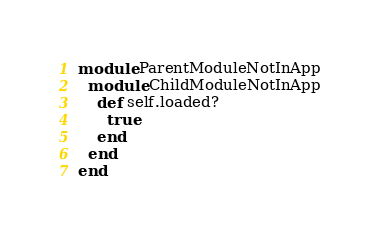<code> <loc_0><loc_0><loc_500><loc_500><_Ruby_>module ParentModuleNotInApp
  module ChildModuleNotInApp
    def self.loaded?
      true
    end
  end
end
</code> 